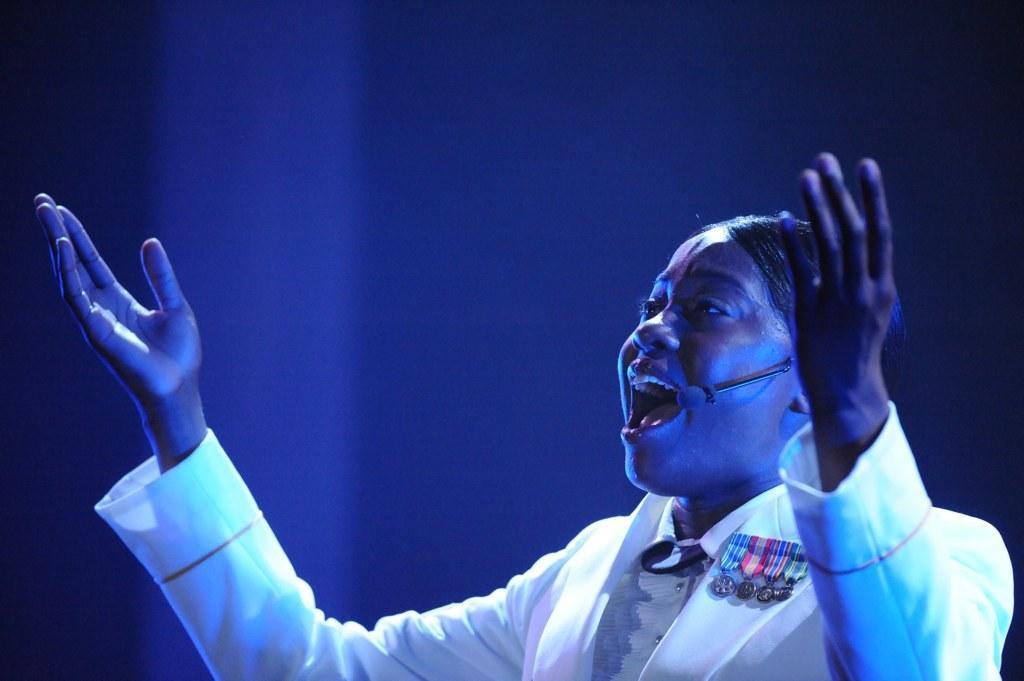How would you summarize this image in a sentence or two? In this image we can see a person with a mic. On the dress there is a badge. In the background it is blue color. 